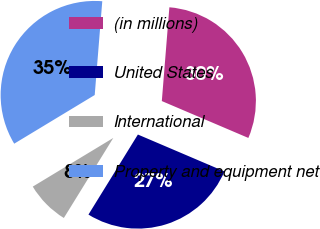Convert chart to OTSL. <chart><loc_0><loc_0><loc_500><loc_500><pie_chart><fcel>(in millions)<fcel>United States<fcel>International<fcel>Property and equipment net<nl><fcel>30.13%<fcel>27.39%<fcel>7.54%<fcel>34.93%<nl></chart> 